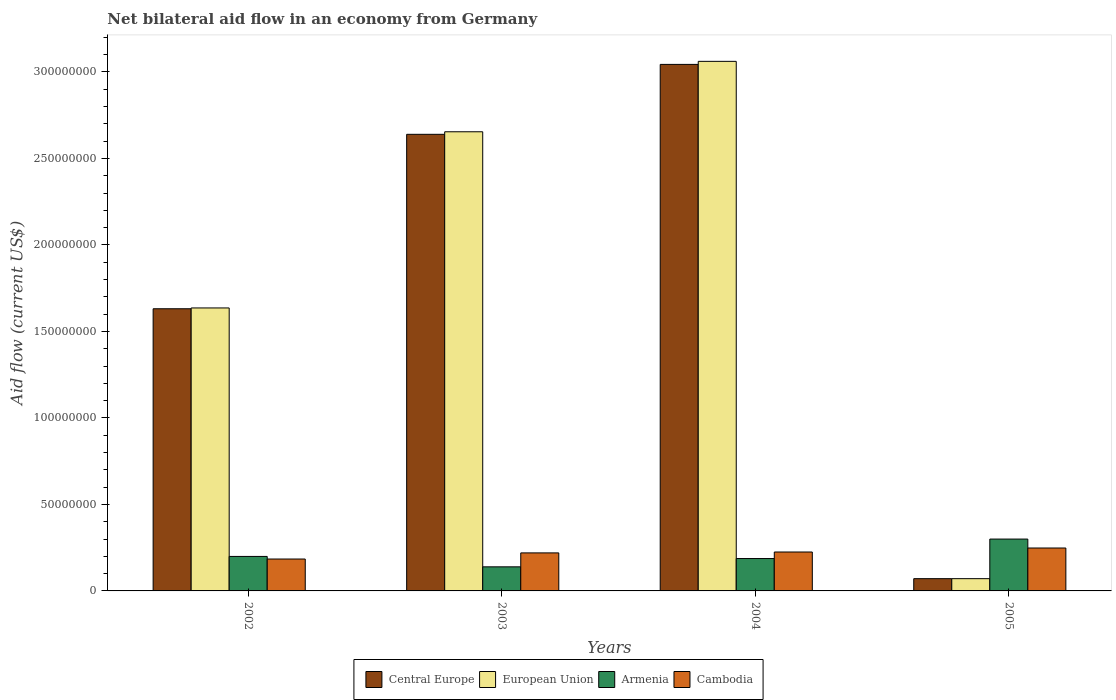How many bars are there on the 2nd tick from the left?
Keep it short and to the point. 4. What is the label of the 1st group of bars from the left?
Your answer should be very brief. 2002. What is the net bilateral aid flow in European Union in 2003?
Your answer should be very brief. 2.65e+08. Across all years, what is the maximum net bilateral aid flow in European Union?
Offer a very short reply. 3.06e+08. Across all years, what is the minimum net bilateral aid flow in European Union?
Your response must be concise. 7.09e+06. In which year was the net bilateral aid flow in European Union maximum?
Give a very brief answer. 2004. In which year was the net bilateral aid flow in Central Europe minimum?
Ensure brevity in your answer.  2005. What is the total net bilateral aid flow in Central Europe in the graph?
Ensure brevity in your answer.  7.39e+08. What is the difference between the net bilateral aid flow in European Union in 2004 and that in 2005?
Provide a succinct answer. 2.99e+08. What is the difference between the net bilateral aid flow in Central Europe in 2005 and the net bilateral aid flow in Armenia in 2002?
Make the answer very short. -1.28e+07. What is the average net bilateral aid flow in Cambodia per year?
Provide a succinct answer. 2.19e+07. In the year 2004, what is the difference between the net bilateral aid flow in Central Europe and net bilateral aid flow in European Union?
Provide a succinct answer. -1.76e+06. What is the ratio of the net bilateral aid flow in European Union in 2002 to that in 2003?
Give a very brief answer. 0.62. Is the net bilateral aid flow in European Union in 2004 less than that in 2005?
Offer a terse response. No. Is the difference between the net bilateral aid flow in Central Europe in 2002 and 2003 greater than the difference between the net bilateral aid flow in European Union in 2002 and 2003?
Your response must be concise. Yes. What is the difference between the highest and the second highest net bilateral aid flow in Armenia?
Your answer should be compact. 1.00e+07. What is the difference between the highest and the lowest net bilateral aid flow in Central Europe?
Make the answer very short. 2.97e+08. Is the sum of the net bilateral aid flow in European Union in 2003 and 2005 greater than the maximum net bilateral aid flow in Central Europe across all years?
Offer a terse response. No. What does the 1st bar from the right in 2004 represents?
Provide a short and direct response. Cambodia. Is it the case that in every year, the sum of the net bilateral aid flow in Central Europe and net bilateral aid flow in Armenia is greater than the net bilateral aid flow in European Union?
Provide a succinct answer. Yes. How many bars are there?
Ensure brevity in your answer.  16. Are all the bars in the graph horizontal?
Provide a succinct answer. No. How many years are there in the graph?
Keep it short and to the point. 4. What is the difference between two consecutive major ticks on the Y-axis?
Make the answer very short. 5.00e+07. Does the graph contain any zero values?
Keep it short and to the point. No. How many legend labels are there?
Offer a very short reply. 4. What is the title of the graph?
Your answer should be compact. Net bilateral aid flow in an economy from Germany. What is the Aid flow (current US$) of Central Europe in 2002?
Offer a very short reply. 1.63e+08. What is the Aid flow (current US$) of European Union in 2002?
Offer a very short reply. 1.64e+08. What is the Aid flow (current US$) of Armenia in 2002?
Keep it short and to the point. 1.99e+07. What is the Aid flow (current US$) of Cambodia in 2002?
Ensure brevity in your answer.  1.84e+07. What is the Aid flow (current US$) in Central Europe in 2003?
Offer a terse response. 2.64e+08. What is the Aid flow (current US$) of European Union in 2003?
Keep it short and to the point. 2.65e+08. What is the Aid flow (current US$) in Armenia in 2003?
Provide a succinct answer. 1.39e+07. What is the Aid flow (current US$) in Cambodia in 2003?
Offer a very short reply. 2.20e+07. What is the Aid flow (current US$) of Central Europe in 2004?
Give a very brief answer. 3.04e+08. What is the Aid flow (current US$) of European Union in 2004?
Your answer should be compact. 3.06e+08. What is the Aid flow (current US$) of Armenia in 2004?
Provide a short and direct response. 1.87e+07. What is the Aid flow (current US$) of Cambodia in 2004?
Keep it short and to the point. 2.25e+07. What is the Aid flow (current US$) in Central Europe in 2005?
Your response must be concise. 7.09e+06. What is the Aid flow (current US$) in European Union in 2005?
Provide a short and direct response. 7.09e+06. What is the Aid flow (current US$) in Armenia in 2005?
Provide a succinct answer. 3.00e+07. What is the Aid flow (current US$) in Cambodia in 2005?
Keep it short and to the point. 2.48e+07. Across all years, what is the maximum Aid flow (current US$) of Central Europe?
Provide a succinct answer. 3.04e+08. Across all years, what is the maximum Aid flow (current US$) of European Union?
Keep it short and to the point. 3.06e+08. Across all years, what is the maximum Aid flow (current US$) in Armenia?
Your response must be concise. 3.00e+07. Across all years, what is the maximum Aid flow (current US$) of Cambodia?
Offer a very short reply. 2.48e+07. Across all years, what is the minimum Aid flow (current US$) of Central Europe?
Your answer should be compact. 7.09e+06. Across all years, what is the minimum Aid flow (current US$) of European Union?
Provide a short and direct response. 7.09e+06. Across all years, what is the minimum Aid flow (current US$) in Armenia?
Give a very brief answer. 1.39e+07. Across all years, what is the minimum Aid flow (current US$) of Cambodia?
Offer a terse response. 1.84e+07. What is the total Aid flow (current US$) in Central Europe in the graph?
Ensure brevity in your answer.  7.39e+08. What is the total Aid flow (current US$) in European Union in the graph?
Your answer should be very brief. 7.42e+08. What is the total Aid flow (current US$) in Armenia in the graph?
Ensure brevity in your answer.  8.26e+07. What is the total Aid flow (current US$) in Cambodia in the graph?
Provide a short and direct response. 8.77e+07. What is the difference between the Aid flow (current US$) of Central Europe in 2002 and that in 2003?
Ensure brevity in your answer.  -1.01e+08. What is the difference between the Aid flow (current US$) of European Union in 2002 and that in 2003?
Keep it short and to the point. -1.02e+08. What is the difference between the Aid flow (current US$) in Armenia in 2002 and that in 2003?
Keep it short and to the point. 6.02e+06. What is the difference between the Aid flow (current US$) in Cambodia in 2002 and that in 2003?
Offer a terse response. -3.54e+06. What is the difference between the Aid flow (current US$) in Central Europe in 2002 and that in 2004?
Offer a terse response. -1.41e+08. What is the difference between the Aid flow (current US$) of European Union in 2002 and that in 2004?
Keep it short and to the point. -1.43e+08. What is the difference between the Aid flow (current US$) in Armenia in 2002 and that in 2004?
Keep it short and to the point. 1.22e+06. What is the difference between the Aid flow (current US$) of Cambodia in 2002 and that in 2004?
Your answer should be very brief. -4.06e+06. What is the difference between the Aid flow (current US$) in Central Europe in 2002 and that in 2005?
Make the answer very short. 1.56e+08. What is the difference between the Aid flow (current US$) in European Union in 2002 and that in 2005?
Offer a terse response. 1.56e+08. What is the difference between the Aid flow (current US$) of Armenia in 2002 and that in 2005?
Keep it short and to the point. -1.00e+07. What is the difference between the Aid flow (current US$) of Cambodia in 2002 and that in 2005?
Your response must be concise. -6.37e+06. What is the difference between the Aid flow (current US$) in Central Europe in 2003 and that in 2004?
Give a very brief answer. -4.04e+07. What is the difference between the Aid flow (current US$) in European Union in 2003 and that in 2004?
Your answer should be compact. -4.07e+07. What is the difference between the Aid flow (current US$) of Armenia in 2003 and that in 2004?
Make the answer very short. -4.80e+06. What is the difference between the Aid flow (current US$) of Cambodia in 2003 and that in 2004?
Offer a terse response. -5.20e+05. What is the difference between the Aid flow (current US$) of Central Europe in 2003 and that in 2005?
Your response must be concise. 2.57e+08. What is the difference between the Aid flow (current US$) in European Union in 2003 and that in 2005?
Provide a short and direct response. 2.58e+08. What is the difference between the Aid flow (current US$) in Armenia in 2003 and that in 2005?
Make the answer very short. -1.61e+07. What is the difference between the Aid flow (current US$) of Cambodia in 2003 and that in 2005?
Your answer should be compact. -2.83e+06. What is the difference between the Aid flow (current US$) of Central Europe in 2004 and that in 2005?
Provide a short and direct response. 2.97e+08. What is the difference between the Aid flow (current US$) in European Union in 2004 and that in 2005?
Offer a terse response. 2.99e+08. What is the difference between the Aid flow (current US$) in Armenia in 2004 and that in 2005?
Keep it short and to the point. -1.13e+07. What is the difference between the Aid flow (current US$) in Cambodia in 2004 and that in 2005?
Provide a short and direct response. -2.31e+06. What is the difference between the Aid flow (current US$) in Central Europe in 2002 and the Aid flow (current US$) in European Union in 2003?
Provide a short and direct response. -1.02e+08. What is the difference between the Aid flow (current US$) in Central Europe in 2002 and the Aid flow (current US$) in Armenia in 2003?
Keep it short and to the point. 1.49e+08. What is the difference between the Aid flow (current US$) in Central Europe in 2002 and the Aid flow (current US$) in Cambodia in 2003?
Your response must be concise. 1.41e+08. What is the difference between the Aid flow (current US$) of European Union in 2002 and the Aid flow (current US$) of Armenia in 2003?
Your answer should be compact. 1.50e+08. What is the difference between the Aid flow (current US$) of European Union in 2002 and the Aid flow (current US$) of Cambodia in 2003?
Provide a short and direct response. 1.42e+08. What is the difference between the Aid flow (current US$) in Armenia in 2002 and the Aid flow (current US$) in Cambodia in 2003?
Make the answer very short. -2.04e+06. What is the difference between the Aid flow (current US$) of Central Europe in 2002 and the Aid flow (current US$) of European Union in 2004?
Ensure brevity in your answer.  -1.43e+08. What is the difference between the Aid flow (current US$) of Central Europe in 2002 and the Aid flow (current US$) of Armenia in 2004?
Ensure brevity in your answer.  1.44e+08. What is the difference between the Aid flow (current US$) in Central Europe in 2002 and the Aid flow (current US$) in Cambodia in 2004?
Ensure brevity in your answer.  1.41e+08. What is the difference between the Aid flow (current US$) in European Union in 2002 and the Aid flow (current US$) in Armenia in 2004?
Provide a succinct answer. 1.45e+08. What is the difference between the Aid flow (current US$) of European Union in 2002 and the Aid flow (current US$) of Cambodia in 2004?
Offer a terse response. 1.41e+08. What is the difference between the Aid flow (current US$) in Armenia in 2002 and the Aid flow (current US$) in Cambodia in 2004?
Your answer should be compact. -2.56e+06. What is the difference between the Aid flow (current US$) in Central Europe in 2002 and the Aid flow (current US$) in European Union in 2005?
Ensure brevity in your answer.  1.56e+08. What is the difference between the Aid flow (current US$) of Central Europe in 2002 and the Aid flow (current US$) of Armenia in 2005?
Provide a short and direct response. 1.33e+08. What is the difference between the Aid flow (current US$) of Central Europe in 2002 and the Aid flow (current US$) of Cambodia in 2005?
Make the answer very short. 1.38e+08. What is the difference between the Aid flow (current US$) of European Union in 2002 and the Aid flow (current US$) of Armenia in 2005?
Provide a short and direct response. 1.34e+08. What is the difference between the Aid flow (current US$) of European Union in 2002 and the Aid flow (current US$) of Cambodia in 2005?
Provide a short and direct response. 1.39e+08. What is the difference between the Aid flow (current US$) of Armenia in 2002 and the Aid flow (current US$) of Cambodia in 2005?
Your answer should be very brief. -4.87e+06. What is the difference between the Aid flow (current US$) of Central Europe in 2003 and the Aid flow (current US$) of European Union in 2004?
Ensure brevity in your answer.  -4.22e+07. What is the difference between the Aid flow (current US$) of Central Europe in 2003 and the Aid flow (current US$) of Armenia in 2004?
Give a very brief answer. 2.45e+08. What is the difference between the Aid flow (current US$) of Central Europe in 2003 and the Aid flow (current US$) of Cambodia in 2004?
Offer a terse response. 2.41e+08. What is the difference between the Aid flow (current US$) in European Union in 2003 and the Aid flow (current US$) in Armenia in 2004?
Your answer should be compact. 2.47e+08. What is the difference between the Aid flow (current US$) in European Union in 2003 and the Aid flow (current US$) in Cambodia in 2004?
Make the answer very short. 2.43e+08. What is the difference between the Aid flow (current US$) of Armenia in 2003 and the Aid flow (current US$) of Cambodia in 2004?
Your answer should be very brief. -8.58e+06. What is the difference between the Aid flow (current US$) in Central Europe in 2003 and the Aid flow (current US$) in European Union in 2005?
Your answer should be compact. 2.57e+08. What is the difference between the Aid flow (current US$) in Central Europe in 2003 and the Aid flow (current US$) in Armenia in 2005?
Ensure brevity in your answer.  2.34e+08. What is the difference between the Aid flow (current US$) in Central Europe in 2003 and the Aid flow (current US$) in Cambodia in 2005?
Provide a succinct answer. 2.39e+08. What is the difference between the Aid flow (current US$) of European Union in 2003 and the Aid flow (current US$) of Armenia in 2005?
Provide a short and direct response. 2.35e+08. What is the difference between the Aid flow (current US$) of European Union in 2003 and the Aid flow (current US$) of Cambodia in 2005?
Keep it short and to the point. 2.41e+08. What is the difference between the Aid flow (current US$) of Armenia in 2003 and the Aid flow (current US$) of Cambodia in 2005?
Provide a short and direct response. -1.09e+07. What is the difference between the Aid flow (current US$) in Central Europe in 2004 and the Aid flow (current US$) in European Union in 2005?
Offer a very short reply. 2.97e+08. What is the difference between the Aid flow (current US$) in Central Europe in 2004 and the Aid flow (current US$) in Armenia in 2005?
Your response must be concise. 2.74e+08. What is the difference between the Aid flow (current US$) in Central Europe in 2004 and the Aid flow (current US$) in Cambodia in 2005?
Offer a terse response. 2.80e+08. What is the difference between the Aid flow (current US$) of European Union in 2004 and the Aid flow (current US$) of Armenia in 2005?
Give a very brief answer. 2.76e+08. What is the difference between the Aid flow (current US$) of European Union in 2004 and the Aid flow (current US$) of Cambodia in 2005?
Offer a very short reply. 2.81e+08. What is the difference between the Aid flow (current US$) in Armenia in 2004 and the Aid flow (current US$) in Cambodia in 2005?
Your response must be concise. -6.09e+06. What is the average Aid flow (current US$) of Central Europe per year?
Your answer should be compact. 1.85e+08. What is the average Aid flow (current US$) in European Union per year?
Provide a succinct answer. 1.86e+08. What is the average Aid flow (current US$) in Armenia per year?
Your answer should be compact. 2.06e+07. What is the average Aid flow (current US$) in Cambodia per year?
Keep it short and to the point. 2.19e+07. In the year 2002, what is the difference between the Aid flow (current US$) in Central Europe and Aid flow (current US$) in European Union?
Provide a short and direct response. -4.70e+05. In the year 2002, what is the difference between the Aid flow (current US$) of Central Europe and Aid flow (current US$) of Armenia?
Keep it short and to the point. 1.43e+08. In the year 2002, what is the difference between the Aid flow (current US$) in Central Europe and Aid flow (current US$) in Cambodia?
Your answer should be compact. 1.45e+08. In the year 2002, what is the difference between the Aid flow (current US$) in European Union and Aid flow (current US$) in Armenia?
Make the answer very short. 1.44e+08. In the year 2002, what is the difference between the Aid flow (current US$) of European Union and Aid flow (current US$) of Cambodia?
Offer a very short reply. 1.45e+08. In the year 2002, what is the difference between the Aid flow (current US$) in Armenia and Aid flow (current US$) in Cambodia?
Ensure brevity in your answer.  1.50e+06. In the year 2003, what is the difference between the Aid flow (current US$) in Central Europe and Aid flow (current US$) in European Union?
Your answer should be compact. -1.47e+06. In the year 2003, what is the difference between the Aid flow (current US$) in Central Europe and Aid flow (current US$) in Armenia?
Keep it short and to the point. 2.50e+08. In the year 2003, what is the difference between the Aid flow (current US$) in Central Europe and Aid flow (current US$) in Cambodia?
Ensure brevity in your answer.  2.42e+08. In the year 2003, what is the difference between the Aid flow (current US$) in European Union and Aid flow (current US$) in Armenia?
Provide a succinct answer. 2.52e+08. In the year 2003, what is the difference between the Aid flow (current US$) of European Union and Aid flow (current US$) of Cambodia?
Provide a succinct answer. 2.43e+08. In the year 2003, what is the difference between the Aid flow (current US$) in Armenia and Aid flow (current US$) in Cambodia?
Keep it short and to the point. -8.06e+06. In the year 2004, what is the difference between the Aid flow (current US$) in Central Europe and Aid flow (current US$) in European Union?
Make the answer very short. -1.76e+06. In the year 2004, what is the difference between the Aid flow (current US$) of Central Europe and Aid flow (current US$) of Armenia?
Offer a terse response. 2.86e+08. In the year 2004, what is the difference between the Aid flow (current US$) in Central Europe and Aid flow (current US$) in Cambodia?
Offer a very short reply. 2.82e+08. In the year 2004, what is the difference between the Aid flow (current US$) of European Union and Aid flow (current US$) of Armenia?
Your response must be concise. 2.87e+08. In the year 2004, what is the difference between the Aid flow (current US$) in European Union and Aid flow (current US$) in Cambodia?
Provide a succinct answer. 2.84e+08. In the year 2004, what is the difference between the Aid flow (current US$) in Armenia and Aid flow (current US$) in Cambodia?
Keep it short and to the point. -3.78e+06. In the year 2005, what is the difference between the Aid flow (current US$) of Central Europe and Aid flow (current US$) of Armenia?
Make the answer very short. -2.29e+07. In the year 2005, what is the difference between the Aid flow (current US$) in Central Europe and Aid flow (current US$) in Cambodia?
Your answer should be very brief. -1.77e+07. In the year 2005, what is the difference between the Aid flow (current US$) of European Union and Aid flow (current US$) of Armenia?
Your response must be concise. -2.29e+07. In the year 2005, what is the difference between the Aid flow (current US$) of European Union and Aid flow (current US$) of Cambodia?
Your response must be concise. -1.77e+07. In the year 2005, what is the difference between the Aid flow (current US$) of Armenia and Aid flow (current US$) of Cambodia?
Ensure brevity in your answer.  5.17e+06. What is the ratio of the Aid flow (current US$) in Central Europe in 2002 to that in 2003?
Provide a succinct answer. 0.62. What is the ratio of the Aid flow (current US$) of European Union in 2002 to that in 2003?
Ensure brevity in your answer.  0.62. What is the ratio of the Aid flow (current US$) in Armenia in 2002 to that in 2003?
Your answer should be very brief. 1.43. What is the ratio of the Aid flow (current US$) of Cambodia in 2002 to that in 2003?
Offer a terse response. 0.84. What is the ratio of the Aid flow (current US$) in Central Europe in 2002 to that in 2004?
Make the answer very short. 0.54. What is the ratio of the Aid flow (current US$) in European Union in 2002 to that in 2004?
Keep it short and to the point. 0.53. What is the ratio of the Aid flow (current US$) of Armenia in 2002 to that in 2004?
Your response must be concise. 1.07. What is the ratio of the Aid flow (current US$) in Cambodia in 2002 to that in 2004?
Make the answer very short. 0.82. What is the ratio of the Aid flow (current US$) of Central Europe in 2002 to that in 2005?
Offer a terse response. 23.01. What is the ratio of the Aid flow (current US$) of European Union in 2002 to that in 2005?
Offer a very short reply. 23.07. What is the ratio of the Aid flow (current US$) of Armenia in 2002 to that in 2005?
Give a very brief answer. 0.67. What is the ratio of the Aid flow (current US$) of Cambodia in 2002 to that in 2005?
Provide a short and direct response. 0.74. What is the ratio of the Aid flow (current US$) of Central Europe in 2003 to that in 2004?
Offer a very short reply. 0.87. What is the ratio of the Aid flow (current US$) in European Union in 2003 to that in 2004?
Provide a succinct answer. 0.87. What is the ratio of the Aid flow (current US$) of Armenia in 2003 to that in 2004?
Provide a short and direct response. 0.74. What is the ratio of the Aid flow (current US$) of Cambodia in 2003 to that in 2004?
Keep it short and to the point. 0.98. What is the ratio of the Aid flow (current US$) in Central Europe in 2003 to that in 2005?
Your response must be concise. 37.23. What is the ratio of the Aid flow (current US$) in European Union in 2003 to that in 2005?
Give a very brief answer. 37.44. What is the ratio of the Aid flow (current US$) of Armenia in 2003 to that in 2005?
Keep it short and to the point. 0.46. What is the ratio of the Aid flow (current US$) of Cambodia in 2003 to that in 2005?
Keep it short and to the point. 0.89. What is the ratio of the Aid flow (current US$) in Central Europe in 2004 to that in 2005?
Provide a succinct answer. 42.93. What is the ratio of the Aid flow (current US$) in European Union in 2004 to that in 2005?
Ensure brevity in your answer.  43.18. What is the ratio of the Aid flow (current US$) of Armenia in 2004 to that in 2005?
Your response must be concise. 0.62. What is the ratio of the Aid flow (current US$) of Cambodia in 2004 to that in 2005?
Your answer should be compact. 0.91. What is the difference between the highest and the second highest Aid flow (current US$) of Central Europe?
Offer a very short reply. 4.04e+07. What is the difference between the highest and the second highest Aid flow (current US$) in European Union?
Your answer should be very brief. 4.07e+07. What is the difference between the highest and the second highest Aid flow (current US$) of Armenia?
Your answer should be very brief. 1.00e+07. What is the difference between the highest and the second highest Aid flow (current US$) of Cambodia?
Give a very brief answer. 2.31e+06. What is the difference between the highest and the lowest Aid flow (current US$) in Central Europe?
Your answer should be very brief. 2.97e+08. What is the difference between the highest and the lowest Aid flow (current US$) of European Union?
Provide a short and direct response. 2.99e+08. What is the difference between the highest and the lowest Aid flow (current US$) of Armenia?
Make the answer very short. 1.61e+07. What is the difference between the highest and the lowest Aid flow (current US$) of Cambodia?
Keep it short and to the point. 6.37e+06. 